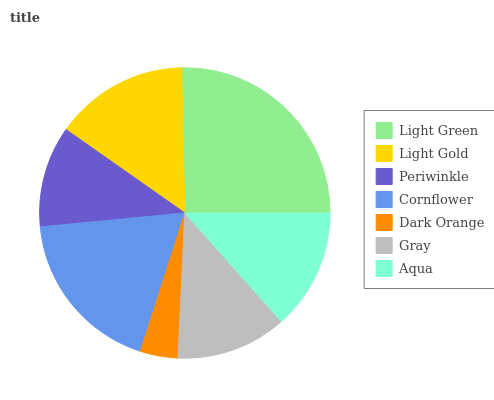Is Dark Orange the minimum?
Answer yes or no. Yes. Is Light Green the maximum?
Answer yes or no. Yes. Is Light Gold the minimum?
Answer yes or no. No. Is Light Gold the maximum?
Answer yes or no. No. Is Light Green greater than Light Gold?
Answer yes or no. Yes. Is Light Gold less than Light Green?
Answer yes or no. Yes. Is Light Gold greater than Light Green?
Answer yes or no. No. Is Light Green less than Light Gold?
Answer yes or no. No. Is Aqua the high median?
Answer yes or no. Yes. Is Aqua the low median?
Answer yes or no. Yes. Is Periwinkle the high median?
Answer yes or no. No. Is Cornflower the low median?
Answer yes or no. No. 